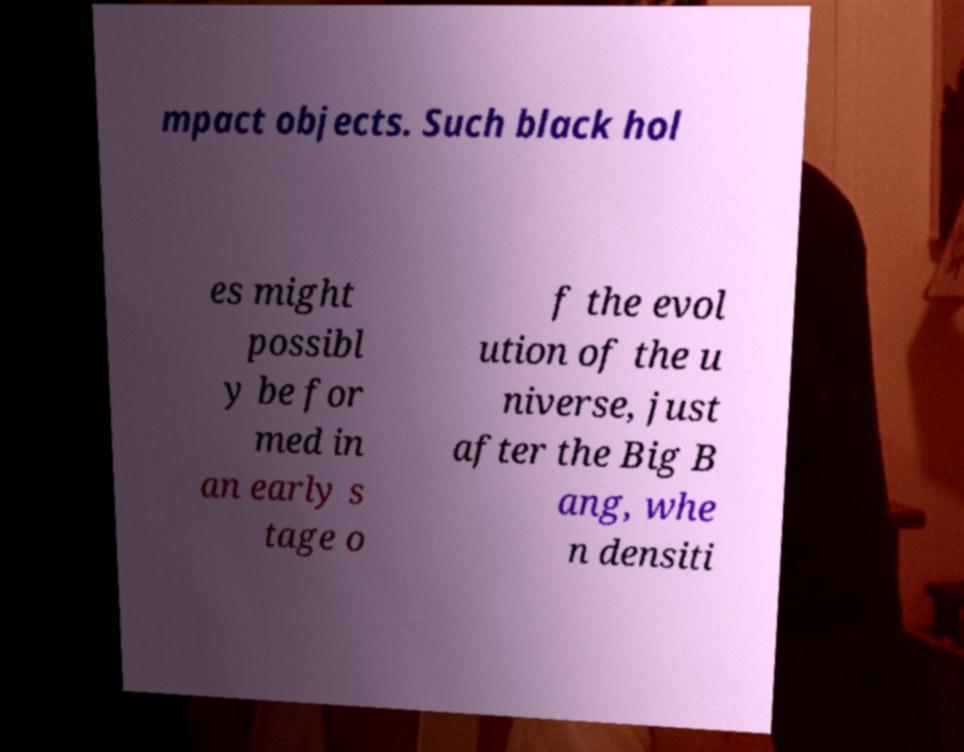Could you assist in decoding the text presented in this image and type it out clearly? mpact objects. Such black hol es might possibl y be for med in an early s tage o f the evol ution of the u niverse, just after the Big B ang, whe n densiti 